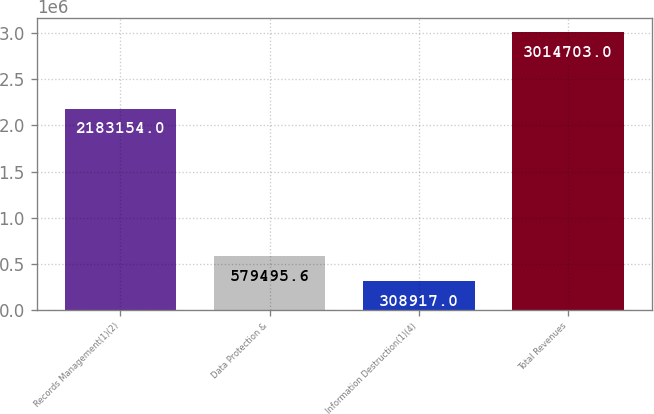Convert chart. <chart><loc_0><loc_0><loc_500><loc_500><bar_chart><fcel>Records Management(1)(2)<fcel>Data Protection &<fcel>Information Destruction(1)(4)<fcel>Total Revenues<nl><fcel>2.18315e+06<fcel>579496<fcel>308917<fcel>3.0147e+06<nl></chart> 